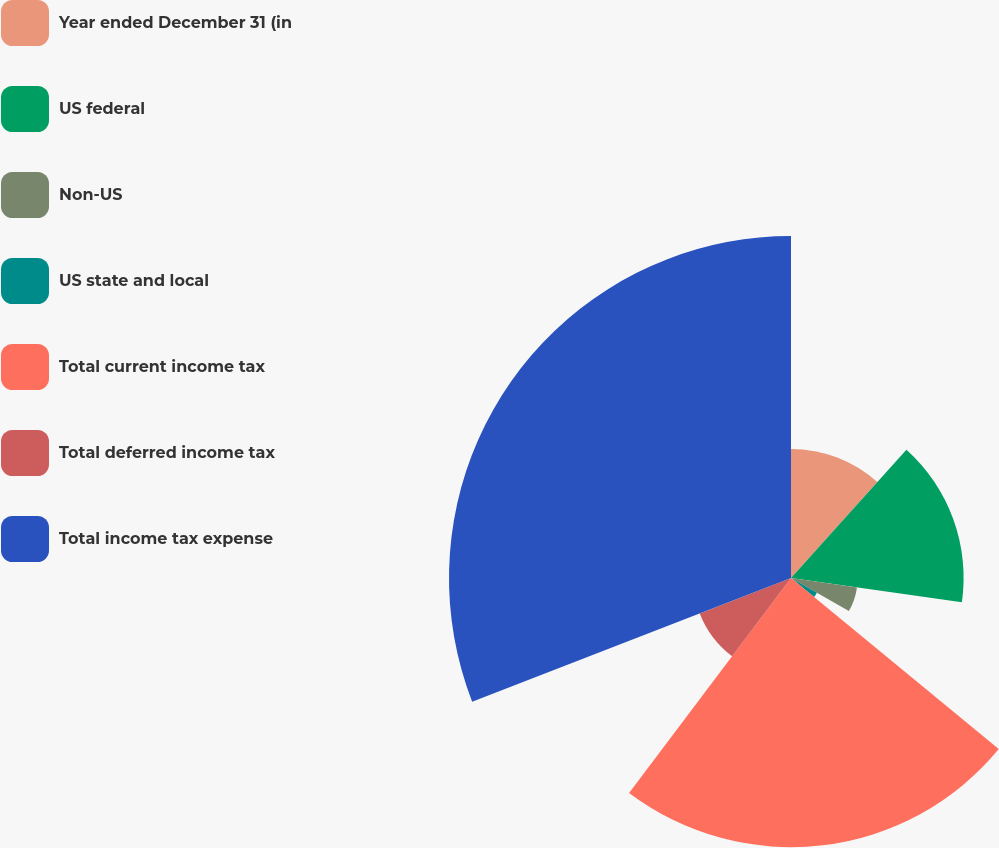Convert chart. <chart><loc_0><loc_0><loc_500><loc_500><pie_chart><fcel>Year ended December 31 (in<fcel>US federal<fcel>Non-US<fcel>US state and local<fcel>Total current income tax<fcel>Total deferred income tax<fcel>Total income tax expense<nl><fcel>11.66%<fcel>15.59%<fcel>6.02%<fcel>2.7%<fcel>24.31%<fcel>8.84%<fcel>30.89%<nl></chart> 